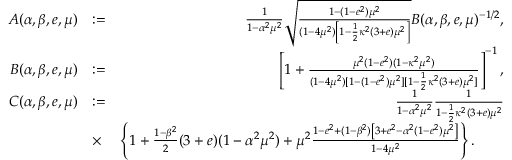Convert formula to latex. <formula><loc_0><loc_0><loc_500><loc_500>\begin{array} { r l r } { A ( \alpha , \beta , e , \mu ) } & { \colon = } & { \frac { 1 } { 1 - \alpha ^ { 2 } \mu ^ { 2 } } \sqrt { \frac { 1 - ( 1 - e ^ { 2 } ) \mu ^ { 2 } } { ( 1 - 4 \mu ^ { 2 } ) \left [ 1 - \frac { 1 } { 2 } \kappa ^ { 2 } ( 3 + e ) \mu ^ { 2 } \right ] } } B ( \alpha , \beta , e , \mu ) ^ { - 1 / 2 } , } \\ { B ( \alpha , \beta , e , \mu ) } & { \colon = } & { \left [ 1 + \frac { \mu ^ { 2 } ( 1 - e ^ { 2 } ) ( 1 - \kappa ^ { 2 } \mu ^ { 2 } ) } { ( 1 - 4 \mu ^ { 2 } ) [ 1 - ( 1 - e ^ { 2 } ) \mu ^ { 2 } ] [ 1 - \frac { 1 } { 2 } \kappa ^ { 2 } ( 3 + e ) \mu ^ { 2 } ] } \right ] ^ { - 1 } , } \\ { C ( \alpha , \beta , e , \mu ) } & { \colon = } & { \frac { 1 } { 1 - \alpha ^ { 2 } \mu ^ { 2 } } \frac { 1 } { 1 - \frac { 1 } { 2 } \kappa ^ { 2 } ( 3 + e ) \mu ^ { 2 } } } \\ & { \times } & { \left \{ 1 + \frac { 1 - \beta ^ { 2 } } { 2 } ( 3 + e ) ( 1 - \alpha ^ { 2 } \mu ^ { 2 } ) + \mu ^ { 2 } \frac { 1 - e ^ { 2 } + ( 1 - \beta ^ { 2 } ) \left [ 3 + e ^ { 2 } - \alpha ^ { 2 } ( 1 - e ^ { 2 } ) \mu ^ { 2 } \right ] } { 1 - 4 \mu ^ { 2 } } \right \} . \quad } \end{array}</formula> 